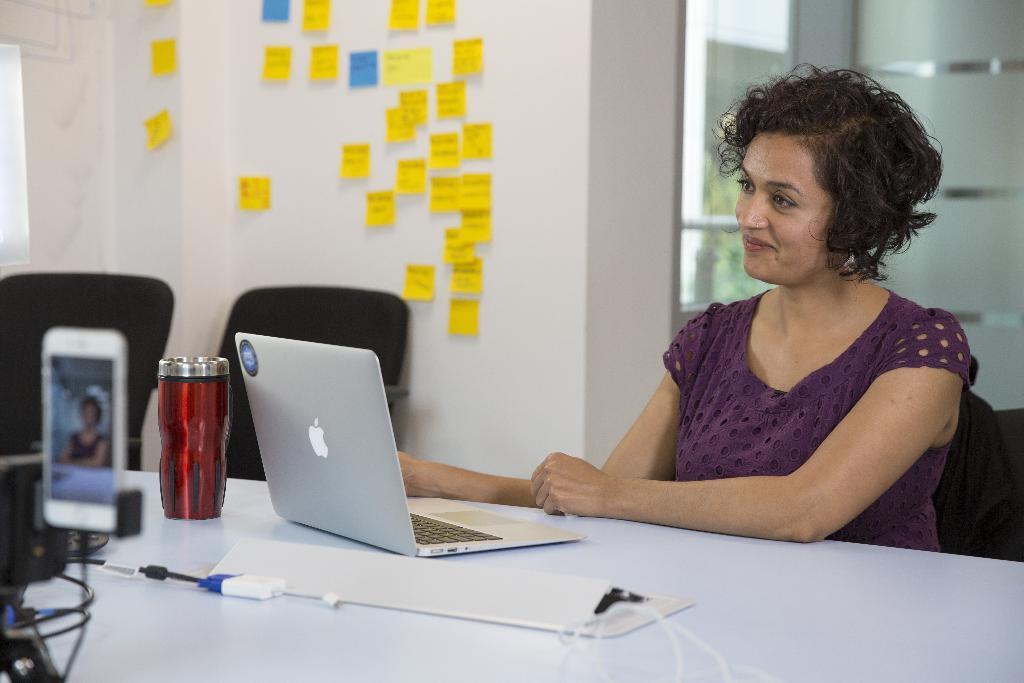Who is the main subject in the image? There is a lady in the image. Where is the lady located in the image? The lady is sitting at the right side of the image. What is in front of the lady? There is a table in front of the lady. What can be seen at the right side of the image? There is a window at the right side of the image. What type of machine is visible in the image? There is no machine present in the image. What kind of cream is being used by the lady in the image? There is no cream visible in the image, nor is the lady using any cream. 